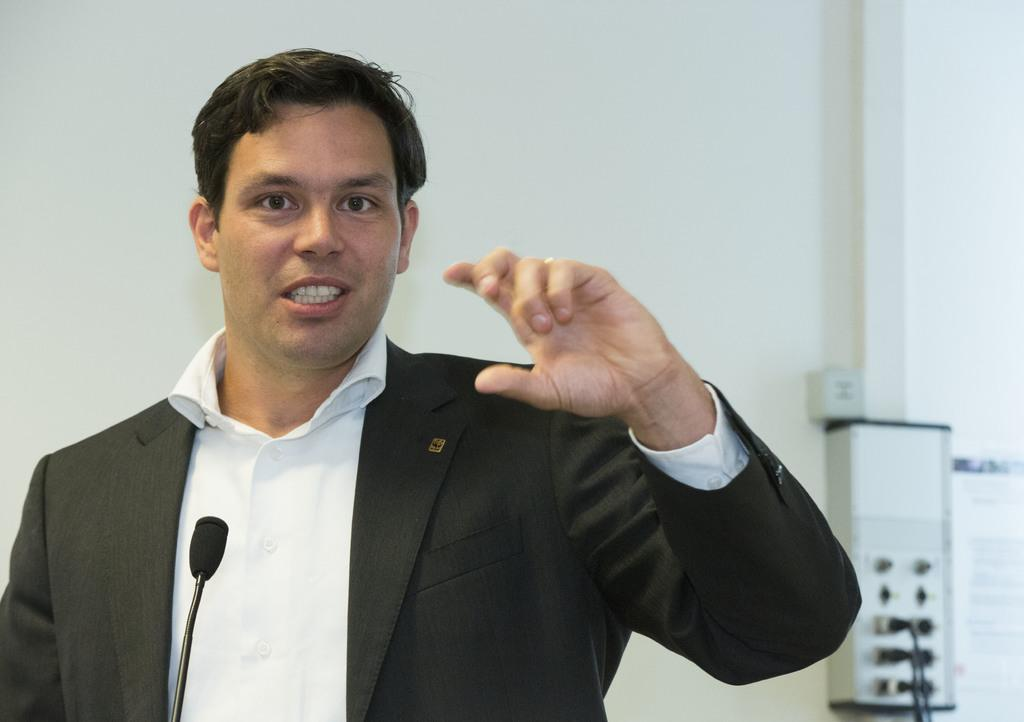What object is in the foreground of the image? There is a microphone in the image. Who is positioned near the microphone? A man is standing behind the microphone. What is the man doing? The man is speaking. What can be seen in the background of the image? There is a wall in the background of the image, and there are wires on the wall. What route does the man's uncle take to visit him in the image? There is no mention of an uncle or a route in the image, so we cannot determine how the man's uncle would visit him. --- Facts: 1. There is a car in the image. 2. The car is red. 3. The car has four wheels. 4. There are people in the car. 5. The car is parked on the street. Absurd Topics: parrot, ocean, mountain Conversation: What type of vehicle is in the image? There is a car in the image. What color is the car? The car is red. How many wheels does the car have? The car has four wheels. Who is inside the car? There are people in the car. Where is the car located? The car is parked on the street. Reasoning: Let's think step by step in order to produce the conversation. We start by identifying the main subject in the image, which is the car. Then, we describe the car's color and the number of wheels it has. Next, we mention the people inside the car, and finally, we describe the car's location, which is on the street. Absurd Question/Answer: Can you see any parrots flying over the ocean in the image? There is no mention of parrots, an ocean, or any flying objects in the image. --- Facts: 1. There is a dog in the image. 2. The dog is brown. 3. The dog is sitting on a rug. 4. There is a toy in the image. 5. The toy is a ball. Absurd Topics: spaceship, volcano, rainbow Conversation: What type of animal is in the image? There is a dog in the image. What color is the dog? The dog is brown. Where is the dog sitting? The dog is sitting on a rug. What object is in the image besides the dog? There is a toy in the image. What type of toy is in the image? The toy is a ball. Reasoning: Let's think step by step in order to produce the conversation. We start by identifying the main subject in the image, which is the dog. Then, we describe the dog's color and the surface it is sitting on, which is a rug. Next, we mention the toy 